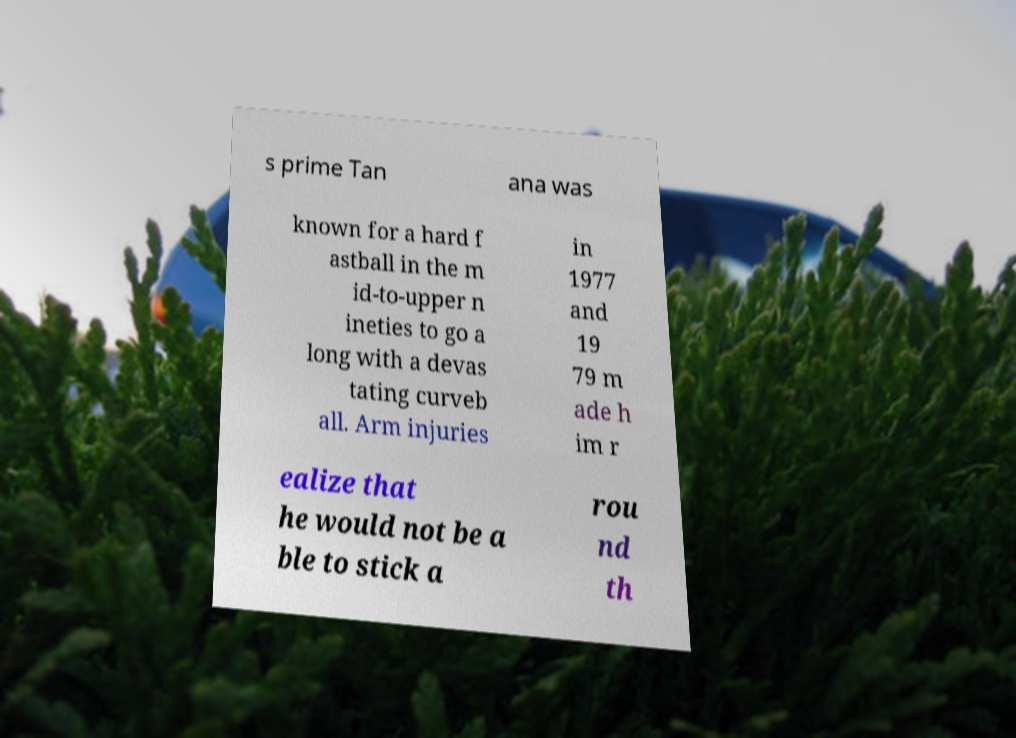What messages or text are displayed in this image? I need them in a readable, typed format. s prime Tan ana was known for a hard f astball in the m id-to-upper n ineties to go a long with a devas tating curveb all. Arm injuries in 1977 and 19 79 m ade h im r ealize that he would not be a ble to stick a rou nd th 